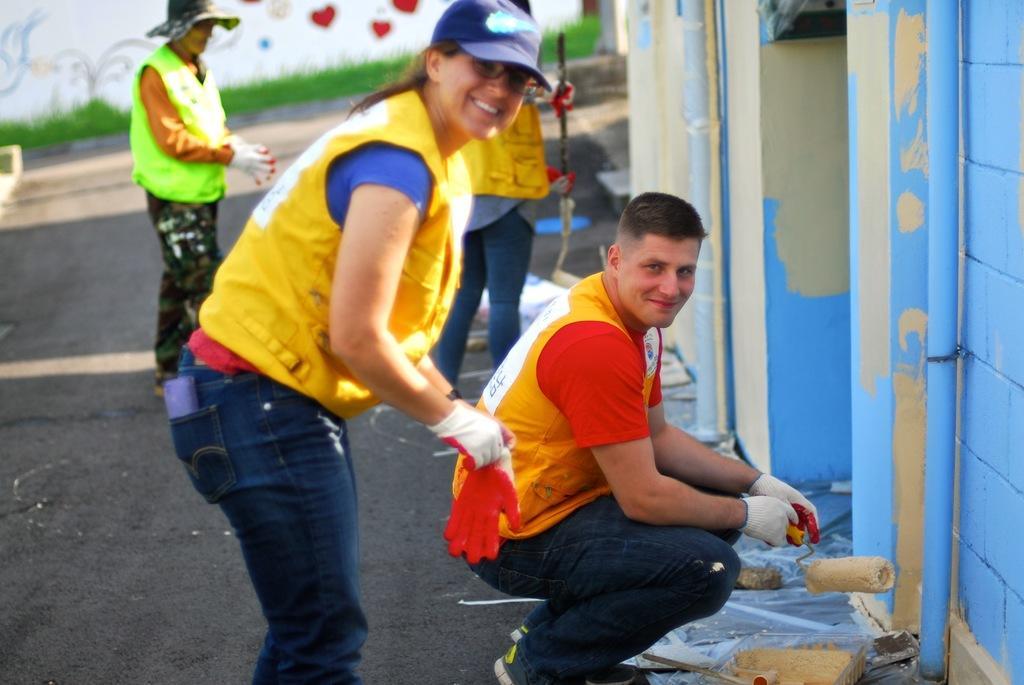How would you summarize this image in a sentence or two? In this picture I can see three people are standing and one man is in a squat position and holding an object in the hand. These people are smiling. This woman is wearing cap. In the background I can see grass. On the right side I can see a wall and blue color pipes. 